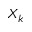Convert formula to latex. <formula><loc_0><loc_0><loc_500><loc_500>X _ { k }</formula> 